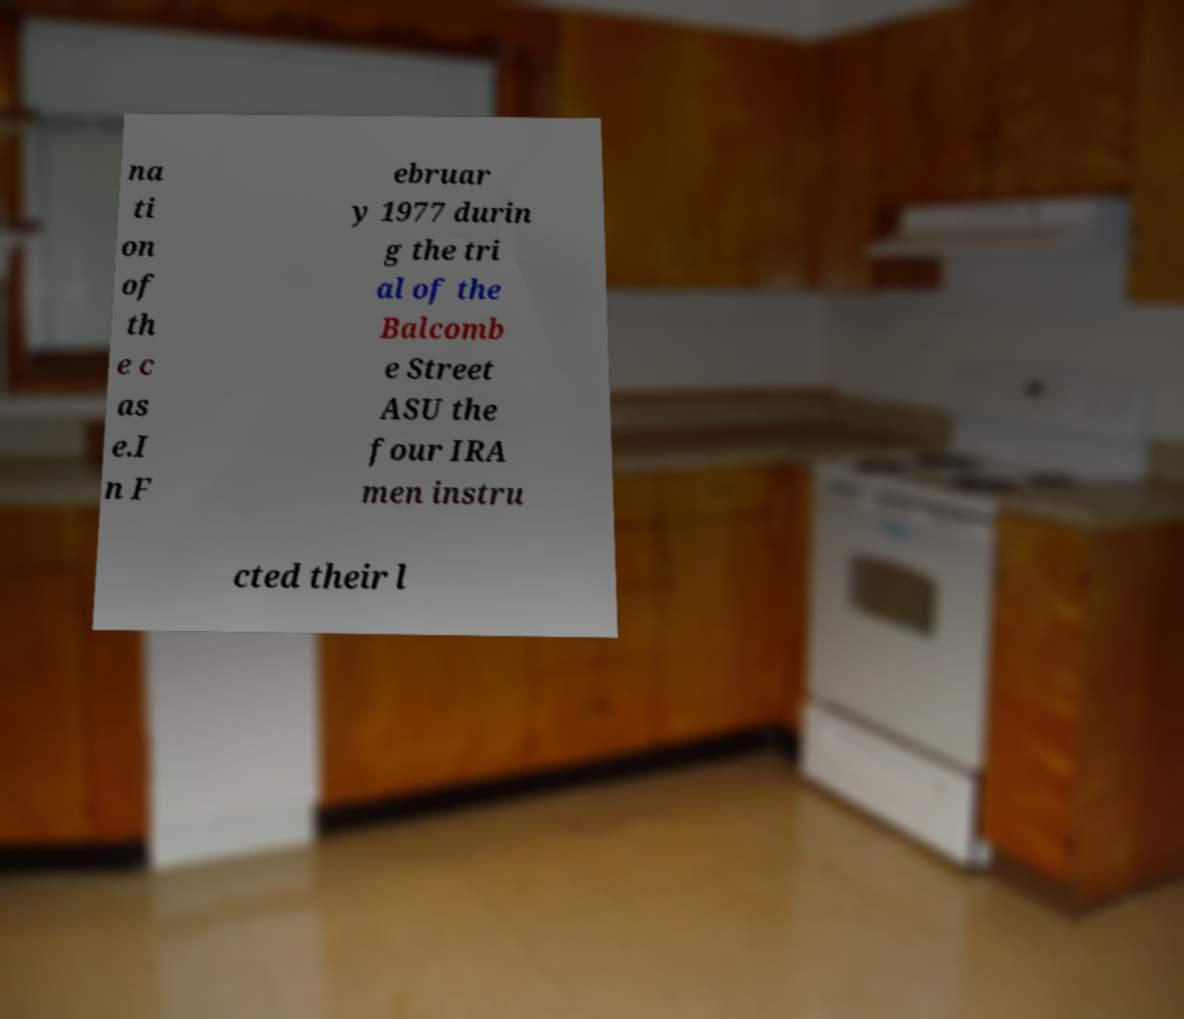For documentation purposes, I need the text within this image transcribed. Could you provide that? na ti on of th e c as e.I n F ebruar y 1977 durin g the tri al of the Balcomb e Street ASU the four IRA men instru cted their l 